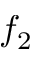<formula> <loc_0><loc_0><loc_500><loc_500>f _ { 2 }</formula> 